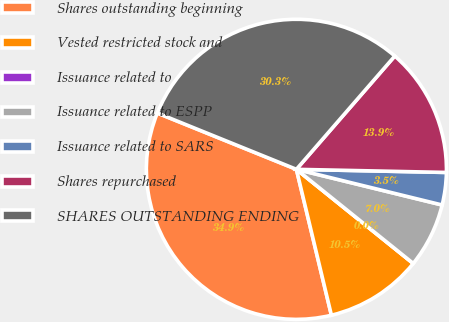<chart> <loc_0><loc_0><loc_500><loc_500><pie_chart><fcel>Shares outstanding beginning<fcel>Vested restricted stock and<fcel>Issuance related to<fcel>Issuance related to ESPP<fcel>Issuance related to SARS<fcel>Shares repurchased<fcel>SHARES OUTSTANDING ENDING<nl><fcel>34.87%<fcel>10.46%<fcel>0.0%<fcel>6.97%<fcel>3.49%<fcel>13.95%<fcel>30.26%<nl></chart> 